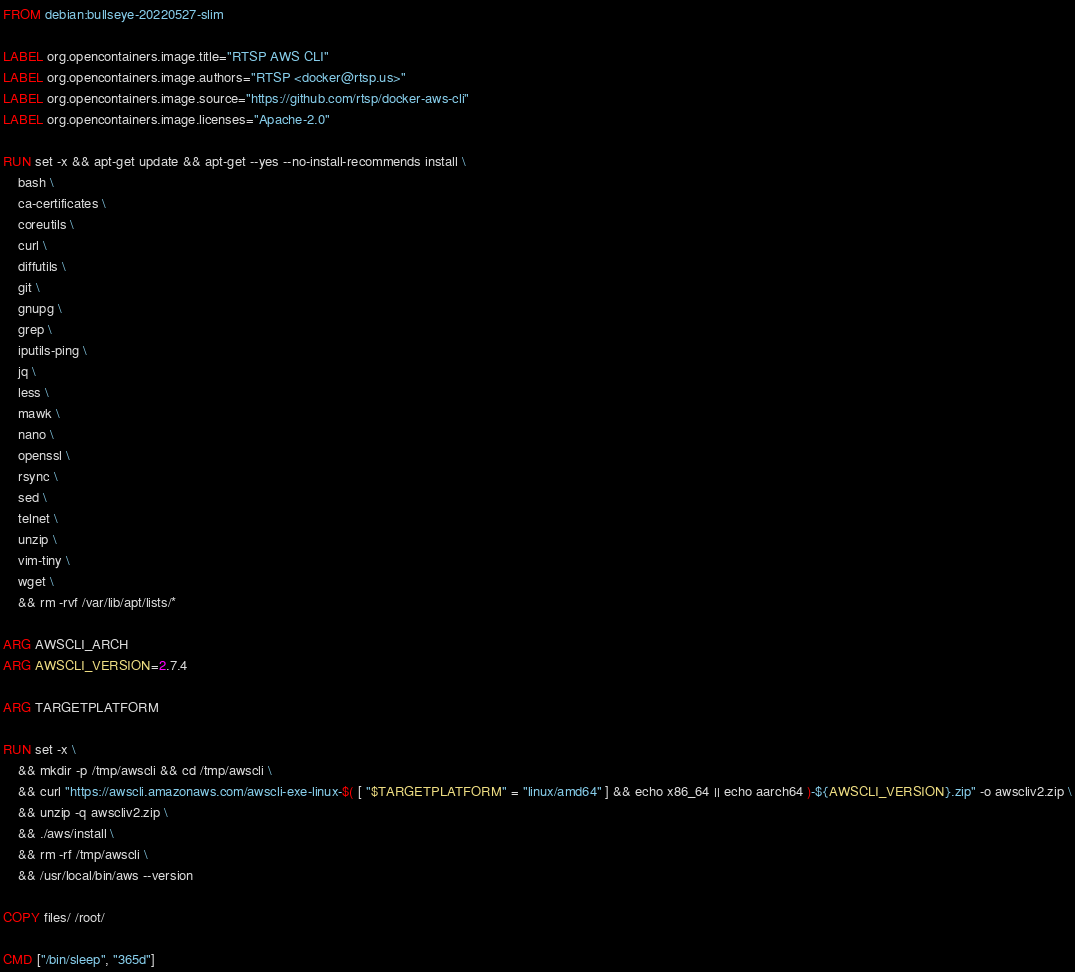Convert code to text. <code><loc_0><loc_0><loc_500><loc_500><_Dockerfile_>FROM debian:bullseye-20220527-slim

LABEL org.opencontainers.image.title="RTSP AWS CLI"
LABEL org.opencontainers.image.authors="RTSP <docker@rtsp.us>"
LABEL org.opencontainers.image.source="https://github.com/rtsp/docker-aws-cli"
LABEL org.opencontainers.image.licenses="Apache-2.0"

RUN set -x && apt-get update && apt-get --yes --no-install-recommends install \
    bash \
    ca-certificates \
    coreutils \
    curl \
    diffutils \
    git \
    gnupg \
    grep \
    iputils-ping \
    jq \
    less \
    mawk \
    nano \
    openssl \
    rsync \
    sed \
    telnet \
    unzip \
    vim-tiny \
    wget \
    && rm -rvf /var/lib/apt/lists/*

ARG AWSCLI_ARCH
ARG AWSCLI_VERSION=2.7.4

ARG TARGETPLATFORM

RUN set -x \
    && mkdir -p /tmp/awscli && cd /tmp/awscli \
    && curl "https://awscli.amazonaws.com/awscli-exe-linux-$( [ "$TARGETPLATFORM" = "linux/amd64" ] && echo x86_64 || echo aarch64 )-${AWSCLI_VERSION}.zip" -o awscliv2.zip \
    && unzip -q awscliv2.zip \
    && ./aws/install \
    && rm -rf /tmp/awscli \
    && /usr/local/bin/aws --version

COPY files/ /root/

CMD ["/bin/sleep", "365d"]
</code> 